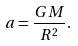Convert formula to latex. <formula><loc_0><loc_0><loc_500><loc_500>a = \frac { G M } { R ^ { 2 } } .</formula> 